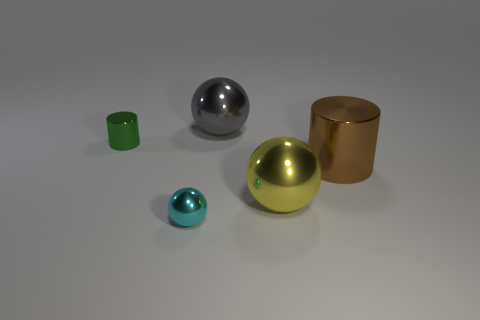Add 3 gray things. How many objects exist? 8 Subtract all yellow spheres. How many spheres are left? 2 Subtract all cyan spheres. How many spheres are left? 2 Subtract all cylinders. How many objects are left? 3 Subtract all purple rubber blocks. Subtract all big metallic cylinders. How many objects are left? 4 Add 1 green metal objects. How many green metal objects are left? 2 Add 3 large metal balls. How many large metal balls exist? 5 Subtract 1 yellow balls. How many objects are left? 4 Subtract 1 cylinders. How many cylinders are left? 1 Subtract all gray cylinders. Subtract all green balls. How many cylinders are left? 2 